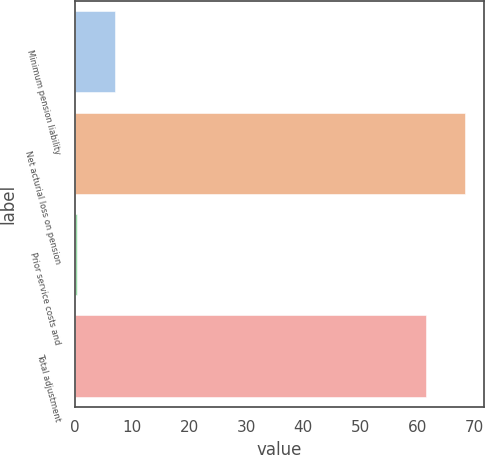Convert chart. <chart><loc_0><loc_0><loc_500><loc_500><bar_chart><fcel>Minimum pension liability<fcel>Net acturial loss on pension<fcel>Prior service costs and<fcel>Total adjustment<nl><fcel>7.1<fcel>68.2<fcel>0.4<fcel>61.5<nl></chart> 